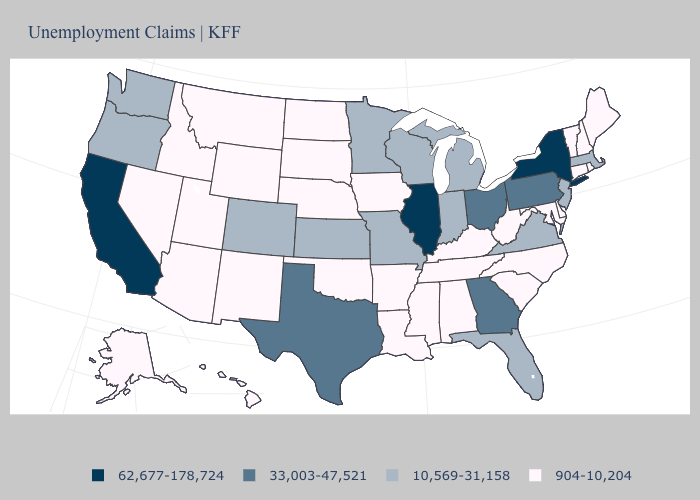Name the states that have a value in the range 904-10,204?
Quick response, please. Alabama, Alaska, Arizona, Arkansas, Connecticut, Delaware, Hawaii, Idaho, Iowa, Kentucky, Louisiana, Maine, Maryland, Mississippi, Montana, Nebraska, Nevada, New Hampshire, New Mexico, North Carolina, North Dakota, Oklahoma, Rhode Island, South Carolina, South Dakota, Tennessee, Utah, Vermont, West Virginia, Wyoming. Does South Dakota have the lowest value in the MidWest?
Be succinct. Yes. Does the first symbol in the legend represent the smallest category?
Give a very brief answer. No. Among the states that border Utah , which have the lowest value?
Short answer required. Arizona, Idaho, Nevada, New Mexico, Wyoming. Does Oklahoma have the lowest value in the USA?
Write a very short answer. Yes. What is the value of Wisconsin?
Keep it brief. 10,569-31,158. What is the highest value in the USA?
Write a very short answer. 62,677-178,724. What is the value of Idaho?
Answer briefly. 904-10,204. Name the states that have a value in the range 62,677-178,724?
Give a very brief answer. California, Illinois, New York. What is the value of North Carolina?
Concise answer only. 904-10,204. What is the value of North Carolina?
Answer briefly. 904-10,204. What is the value of West Virginia?
Give a very brief answer. 904-10,204. Does South Carolina have the same value as Utah?
Answer briefly. Yes. Does Michigan have the lowest value in the MidWest?
Quick response, please. No. Name the states that have a value in the range 904-10,204?
Be succinct. Alabama, Alaska, Arizona, Arkansas, Connecticut, Delaware, Hawaii, Idaho, Iowa, Kentucky, Louisiana, Maine, Maryland, Mississippi, Montana, Nebraska, Nevada, New Hampshire, New Mexico, North Carolina, North Dakota, Oklahoma, Rhode Island, South Carolina, South Dakota, Tennessee, Utah, Vermont, West Virginia, Wyoming. 